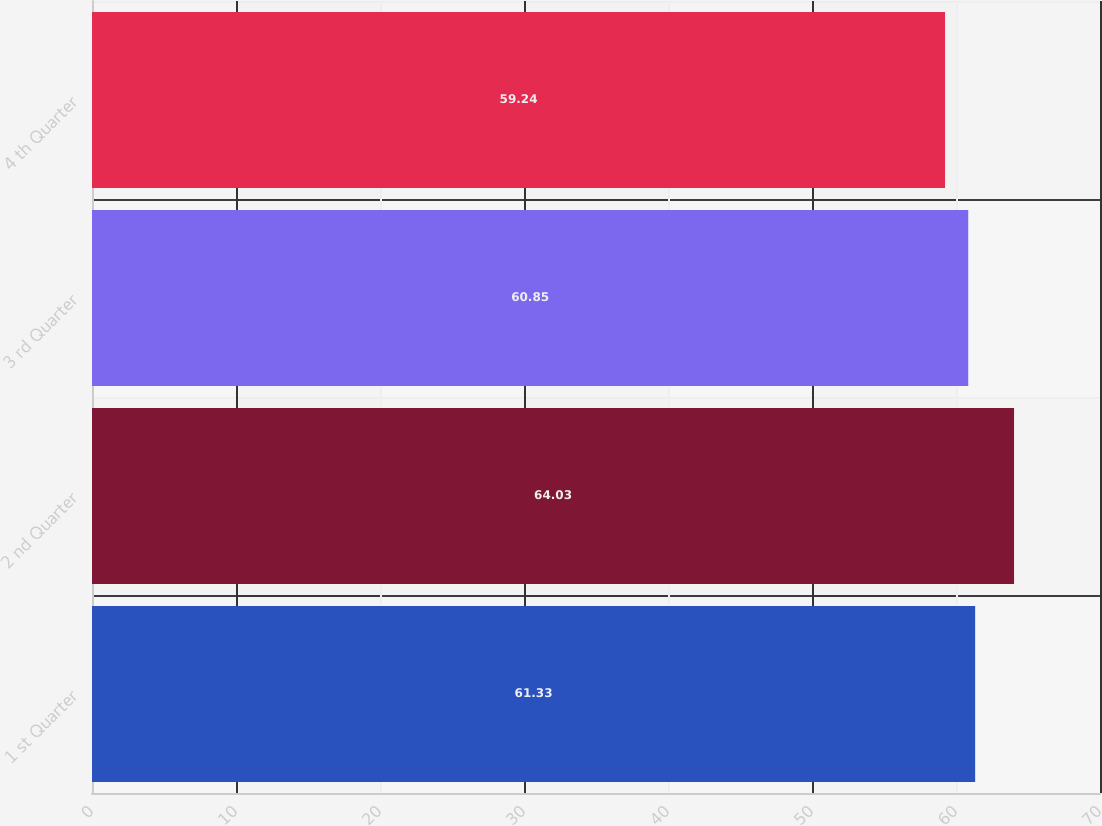<chart> <loc_0><loc_0><loc_500><loc_500><bar_chart><fcel>1 st Quarter<fcel>2 nd Quarter<fcel>3 rd Quarter<fcel>4 th Quarter<nl><fcel>61.33<fcel>64.03<fcel>60.85<fcel>59.24<nl></chart> 